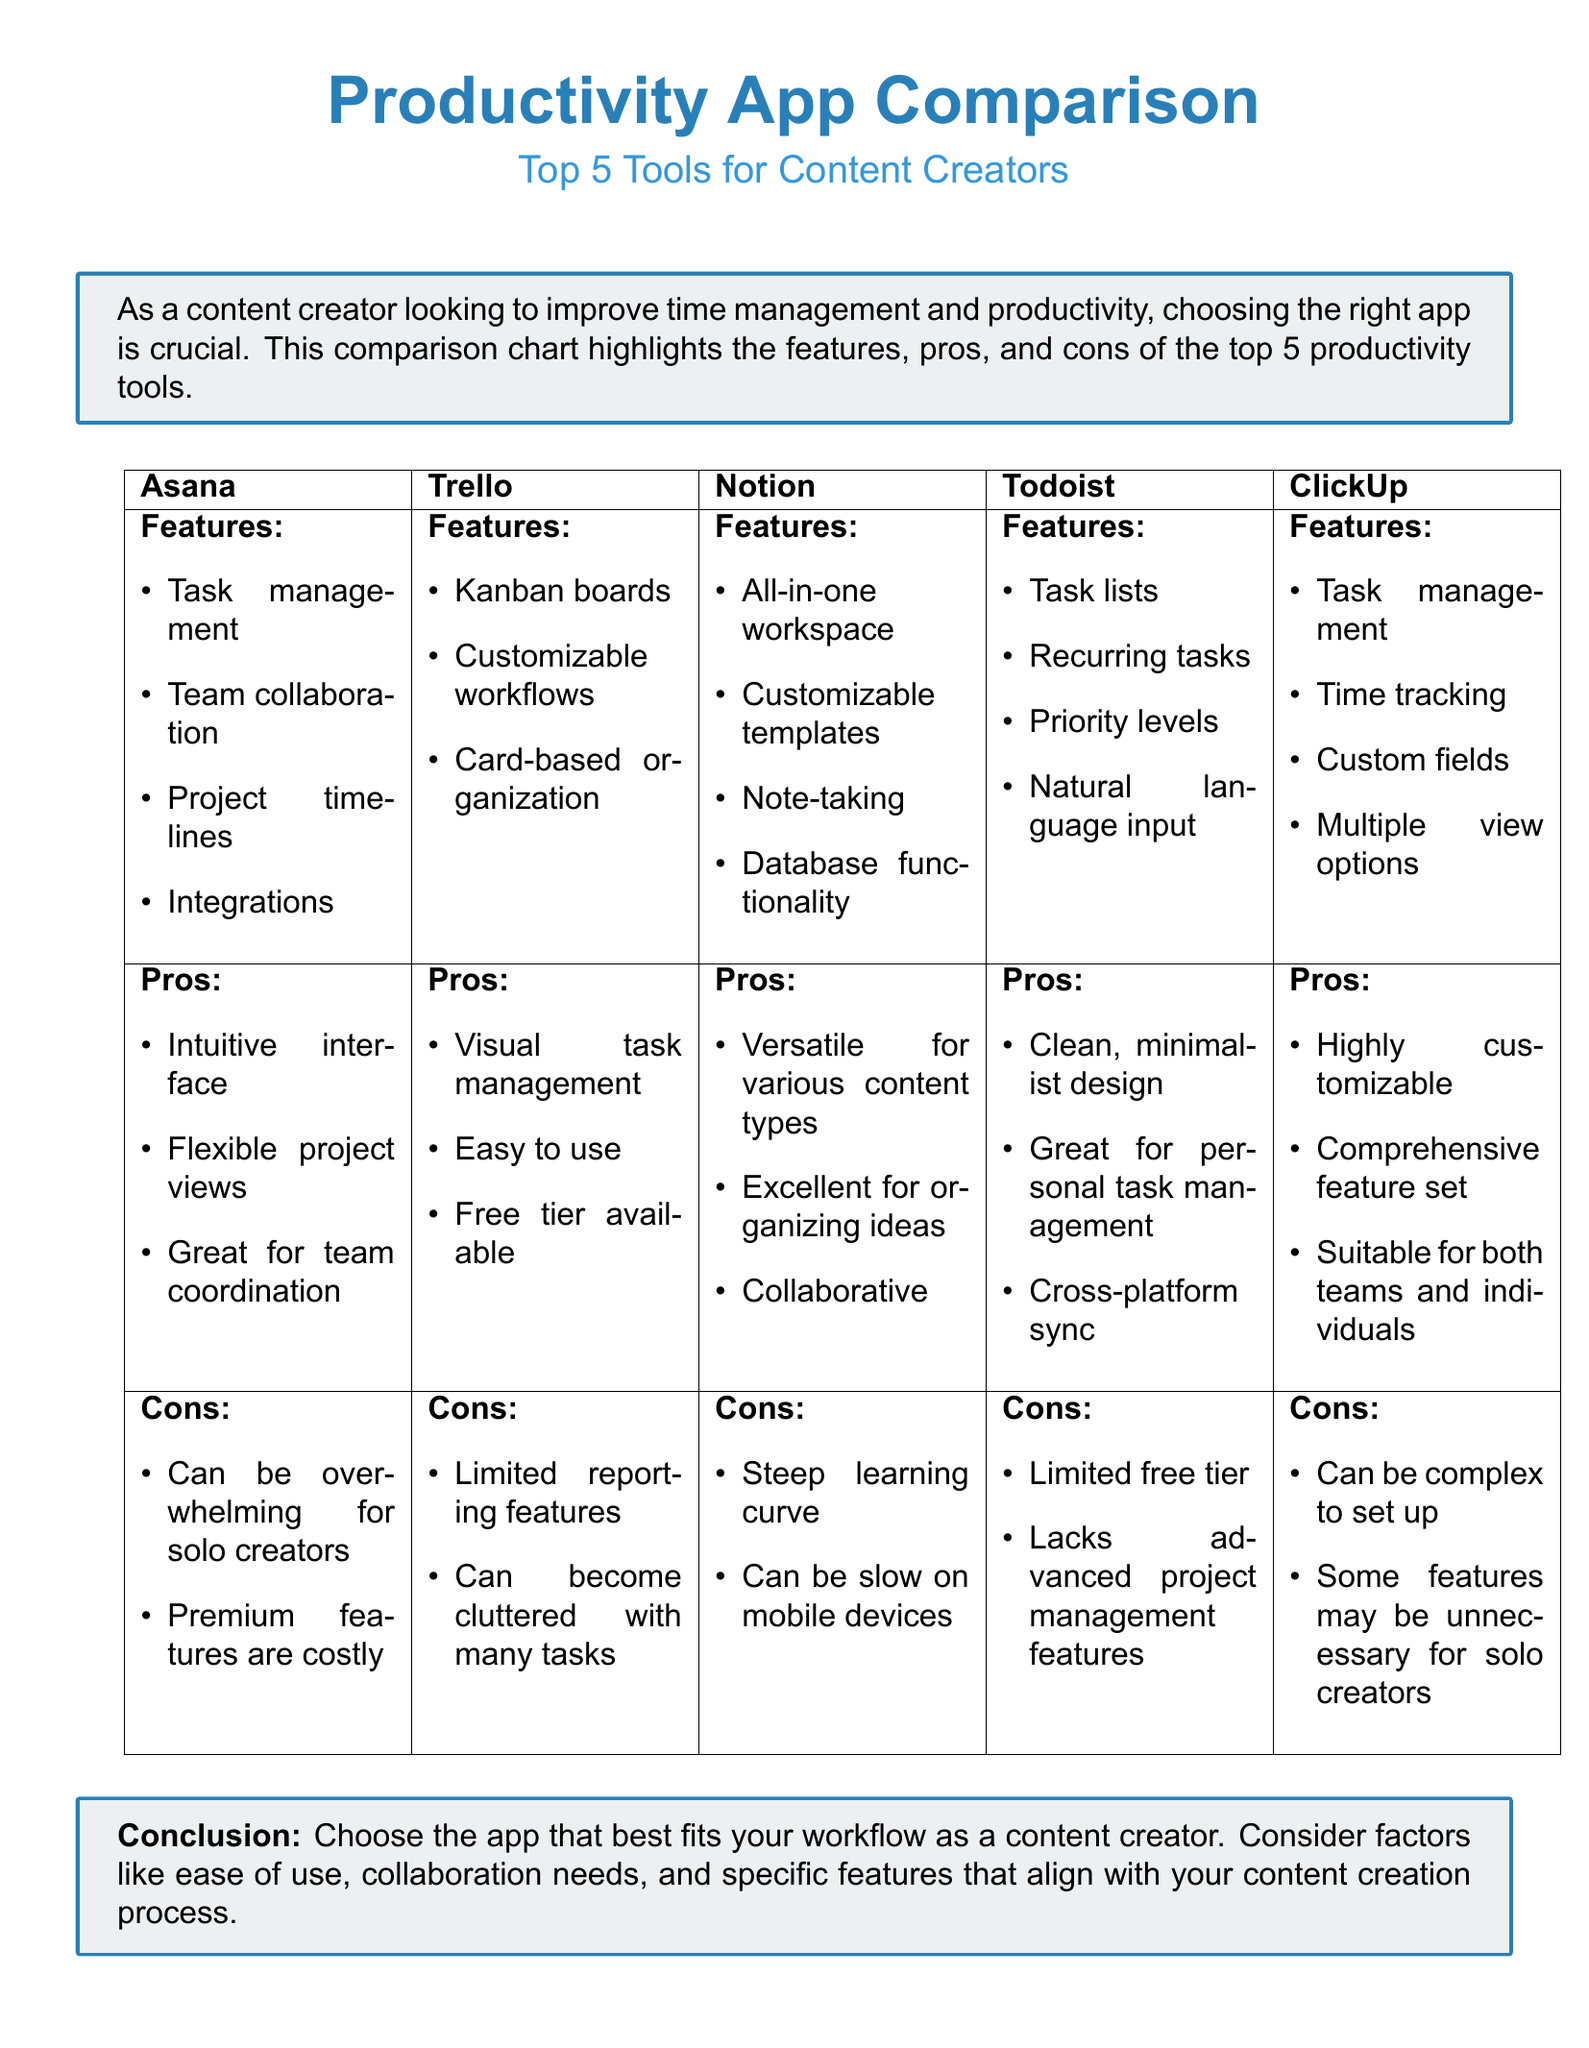What is the title of the document? The title is explicitly stated at the beginning of the document as "Productivity App Comparison: Top 5 Tools for Content Creators."
Answer: Productivity App Comparison: Top 5 Tools for Content Creators How many productivity tools are compared in the document? The document lists five different productivity tools for comparison.
Answer: 5 What feature is unique to Notion compared to the other tools? Notion includes "All-in-one workspace" in its feature set, which isn't mentioned by the other tools.
Answer: All-in-one workspace Which app has the lowest cost feature in the pros? Trello indicates that it has a "Free tier available," making it the lowest cost option in its pros.
Answer: Free tier available What is a con of using Asana? The document explicitly mentions two cons for Asana, one of which is "Can be overwhelming for solo creators."
Answer: Can be overwhelming for solo creators Which app is best for personal task management according to its pros? Todoist is mentioned as "Great for personal task management" in its advantages.
Answer: Todoist What feature is shared between ClickUp and Asana? Both ClickUp and Asana include "Task management" as part of their feature sets.
Answer: Task management What is the main conclusion of the document? The conclusion advises to "Choose the app that best fits your workflow as a content creator."
Answer: Choose the app that best fits your workflow as a content creator 